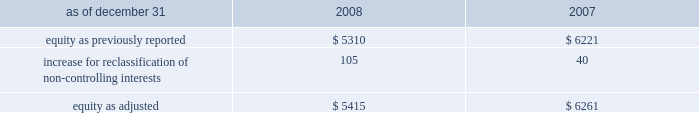The company recognizes the effect of income tax positions only if sustaining those positions is more likely than not .
Changes in recognition or measurement are reflected in the period in which a change in judgment occurs .
The company records penalties and interest related to unrecognized tax benefits in income taxes in the company 2019s consolidated statements of income .
Changes in accounting principles business combinations and noncontrolling interests on january 1 , 2009 , the company adopted revised principles related to business combinations and noncontrolling interests .
The revised principle on business combinations applies to all transactions or other events in which an entity obtains control over one or more businesses .
It requires an acquirer to recognize the assets acquired , the liabilities assumed , and any noncontrolling interest in the acquiree at the acquisition date , measured at their fair values as of that date .
Business combinations achieved in stages require recognition of the identifiable assets and liabilities , as well as the noncontrolling interest in the acquiree , at the full amounts of their fair values when control is obtained .
This revision also changes the requirements for recognizing assets acquired and liabilities assumed arising from contingencies , and requires direct acquisition costs to be expensed .
In addition , it provides certain changes to income tax accounting for business combinations which apply to both new and previously existing business combinations .
In april 2009 , additional guidance was issued which revised certain business combination guidance related to accounting for contingent liabilities assumed in a business combination .
The company has adopted this guidance in conjunction with the adoption of the revised principles related to business combinations .
The adoption of the revised principles related to business combinations has not had a material impact on the consolidated financial statements .
The revised principle related to noncontrolling interests establishes accounting and reporting standards for the noncontrolling interests in a subsidiary and for the deconsolidation of a subsidiary .
The revised principle clarifies that a noncontrolling interest in a subsidiary is an ownership interest in the consolidated entity that should be reported as a separate component of equity in the consolidated statements of financial position .
The revised principle requires retrospective adjustments , for all periods presented , of stockholders 2019 equity and net income for noncontrolling interests .
In addition to these financial reporting changes , the revised principle provides for significant changes in accounting related to changes in ownership of noncontrolling interests .
Changes in aon 2019s controlling financial interests in consolidated subsidiaries that do not result in a loss of control are accounted for as equity transactions similar to treasury stock transactions .
If a change in ownership of a consolidated subsidiary results in a loss of control and deconsolidation , any retained ownership interests are remeasured at fair value with the gain or loss reported in net income .
In previous periods , noncontrolling interests for operating subsidiaries were reported in other general expenses in the consolidated statements of income .
Prior period amounts have been restated to conform to the current year 2019s presentation .
The principal effect on the prior years 2019 balance sheets related to the adoption of the new guidance related to noncontrolling interests is summarized as follows ( in millions ) : .
The revised principle also requires that net income be adjusted to include the net income attributable to the noncontrolling interests and a new separate caption for net income attributable to aon stockholders be presented in the consolidated statements of income .
The adoption of this new guidance increased net income by $ 16 million and $ 13 million for 2008 and 2007 , respectively .
Net .
What is the average equity as adjusted? 
Rationale: it is the sum of both values of equity as adjusted divided by two .
Computations: table_average(equity as adjusted, none)
Answer: 5838.0. 